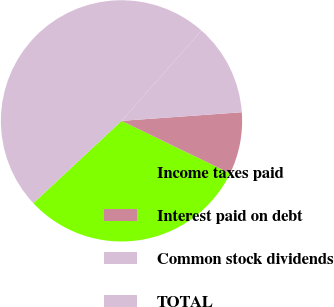Convert chart. <chart><loc_0><loc_0><loc_500><loc_500><pie_chart><fcel>Income taxes paid<fcel>Interest paid on debt<fcel>Common stock dividends<fcel>TOTAL<nl><fcel>30.88%<fcel>8.31%<fcel>12.33%<fcel>48.48%<nl></chart> 